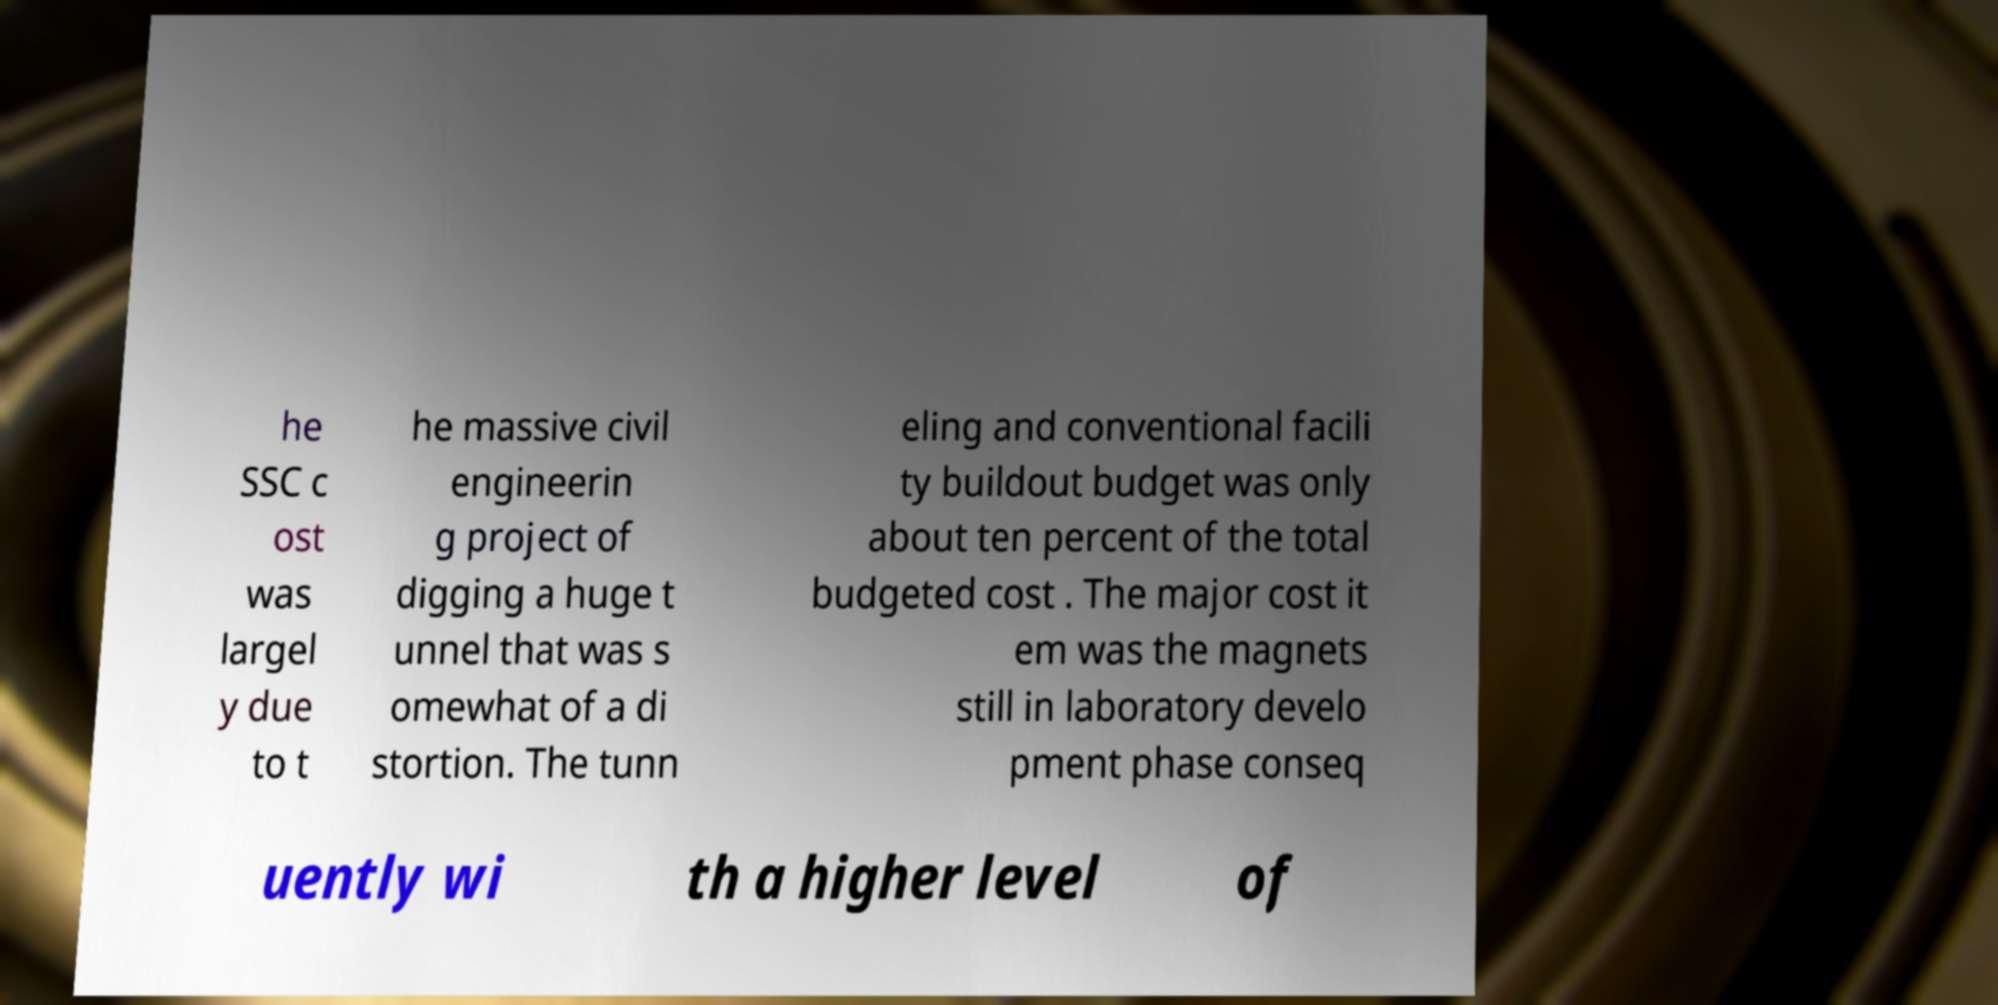For documentation purposes, I need the text within this image transcribed. Could you provide that? he SSC c ost was largel y due to t he massive civil engineerin g project of digging a huge t unnel that was s omewhat of a di stortion. The tunn eling and conventional facili ty buildout budget was only about ten percent of the total budgeted cost . The major cost it em was the magnets still in laboratory develo pment phase conseq uently wi th a higher level of 